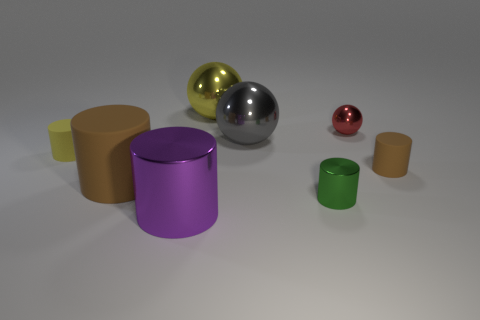Subtract all big metal cylinders. How many cylinders are left? 4 Add 2 tiny balls. How many objects exist? 10 Subtract 3 cylinders. How many cylinders are left? 2 Subtract all yellow balls. How many balls are left? 2 Subtract all cylinders. How many objects are left? 3 Subtract all purple spheres. How many brown cylinders are left? 2 Subtract all small purple matte cylinders. Subtract all small red metallic objects. How many objects are left? 7 Add 5 yellow balls. How many yellow balls are left? 6 Add 6 tiny green metallic blocks. How many tiny green metallic blocks exist? 6 Subtract 1 red balls. How many objects are left? 7 